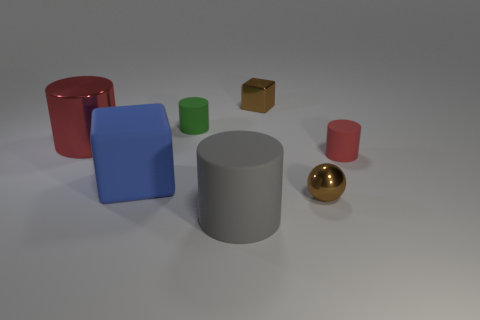Add 1 big gray objects. How many objects exist? 8 Subtract all blocks. How many objects are left? 5 Subtract all big green metallic objects. Subtract all tiny spheres. How many objects are left? 6 Add 7 red metallic cylinders. How many red metallic cylinders are left? 8 Add 1 brown spheres. How many brown spheres exist? 2 Subtract 0 cyan blocks. How many objects are left? 7 